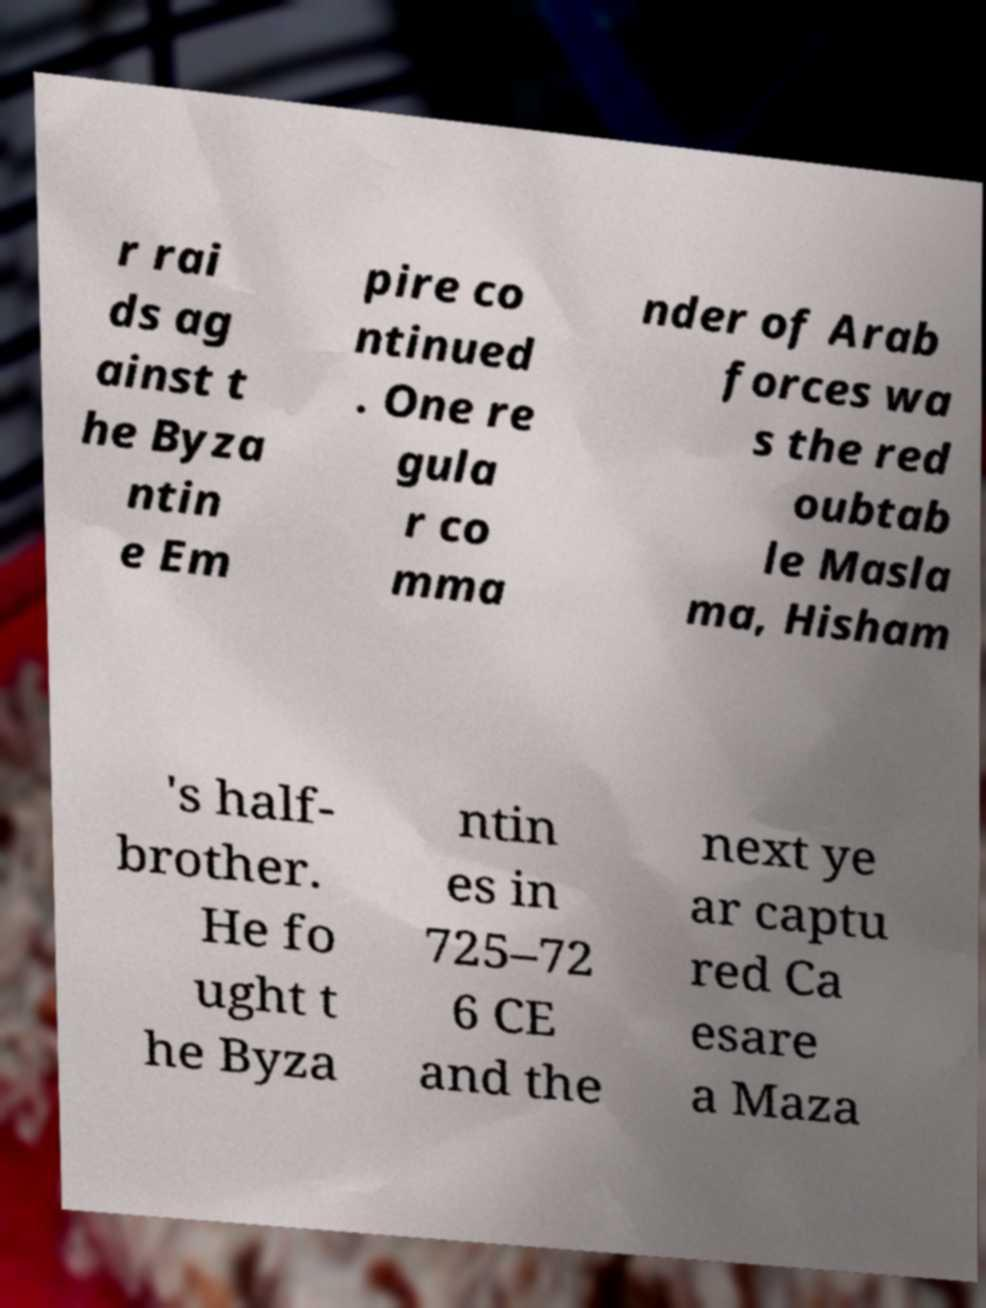I need the written content from this picture converted into text. Can you do that? r rai ds ag ainst t he Byza ntin e Em pire co ntinued . One re gula r co mma nder of Arab forces wa s the red oubtab le Masla ma, Hisham 's half- brother. He fo ught t he Byza ntin es in 725–72 6 CE and the next ye ar captu red Ca esare a Maza 